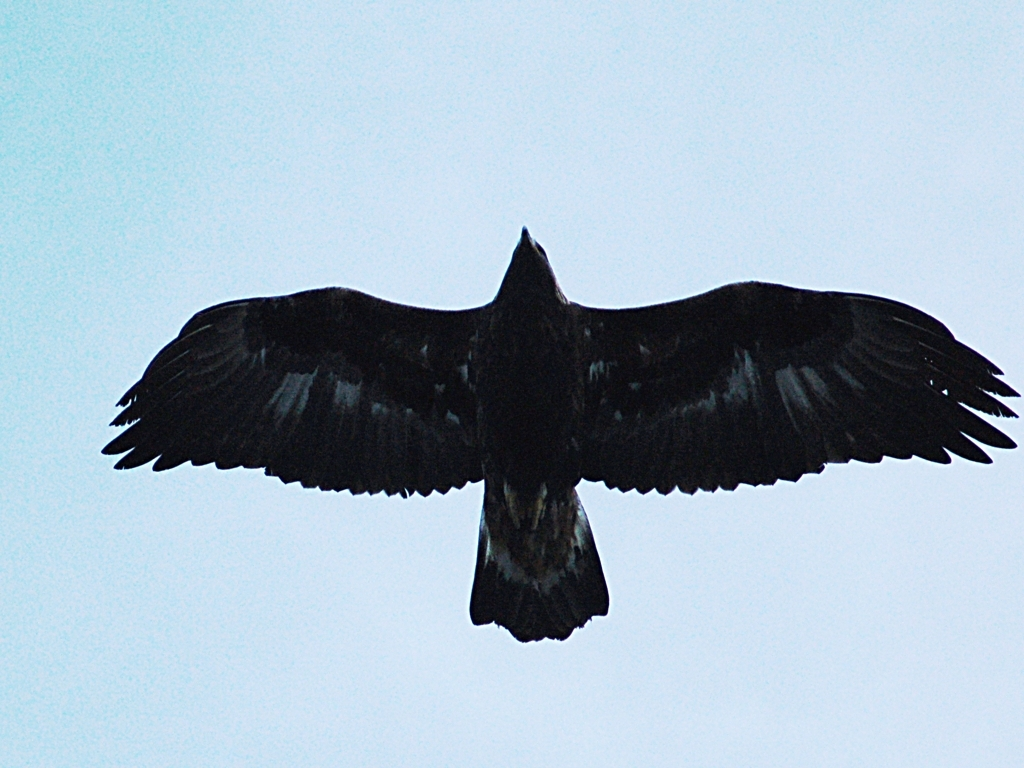What type of bird is shown in this image? The image appears to feature a large bird of prey mid-flight, possibly an eagle or a vulture, judging by the broad wings and distinctive silhouette. Can you deduce anything about its habitat from the photo? It's difficult to determine the specific habitat from this photo due to the lack of environmental details. However, both eagles and vultures often reside in a range of habitats from mountains and forests to grasslands and savannas. 